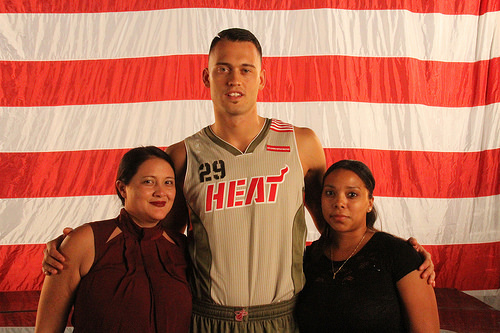<image>
Can you confirm if the flag is behind the person? Yes. From this viewpoint, the flag is positioned behind the person, with the person partially or fully occluding the flag. 